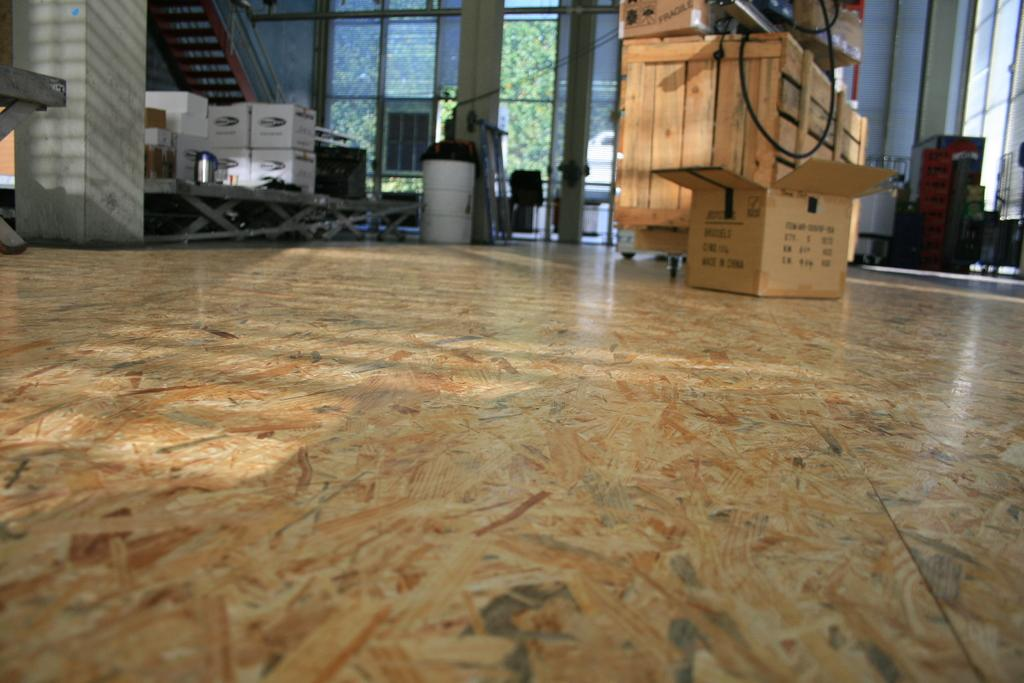What type of structure can be seen in the image? There is a wall in the image. What feature is present in the wall? There is a window in the image. What other architectural element is visible in the image? There is a door in the image. What objects are present near the door? There are boxes and a dustbin in the image. What type of gold ornament is hanging from the door in the image? There is no gold ornament hanging from the door in the image. Can you hear someone coughing in the image? The image is a still picture, so it does not capture any sounds, including coughing. 